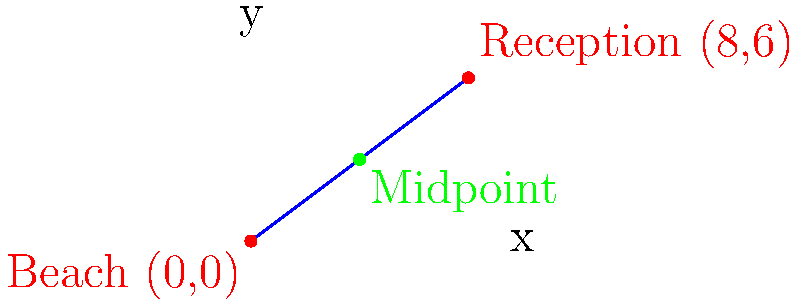As the wedding planner, you need to determine the midpoint of the path between the beach ceremony site and the reception venue. The beach is located at coordinates (0,0), and the reception venue is at (8,6). Calculate the coordinates of the midpoint. To find the midpoint of a line segment, we use the midpoint formula:

$$(x_m, y_m) = (\frac{x_1 + x_2}{2}, \frac{y_1 + y_2}{2})$$

Where $(x_1, y_1)$ is the first point and $(x_2, y_2)$ is the second point.

Given:
- Beach coordinates: $(x_1, y_1) = (0, 0)$
- Reception venue coordinates: $(x_2, y_2) = (8, 6)$

Step 1: Calculate the x-coordinate of the midpoint
$$x_m = \frac{x_1 + x_2}{2} = \frac{0 + 8}{2} = \frac{8}{2} = 4$$

Step 2: Calculate the y-coordinate of the midpoint
$$y_m = \frac{y_1 + y_2}{2} = \frac{0 + 6}{2} = \frac{6}{2} = 3$$

Therefore, the midpoint coordinates are (4, 3).
Answer: (4, 3) 